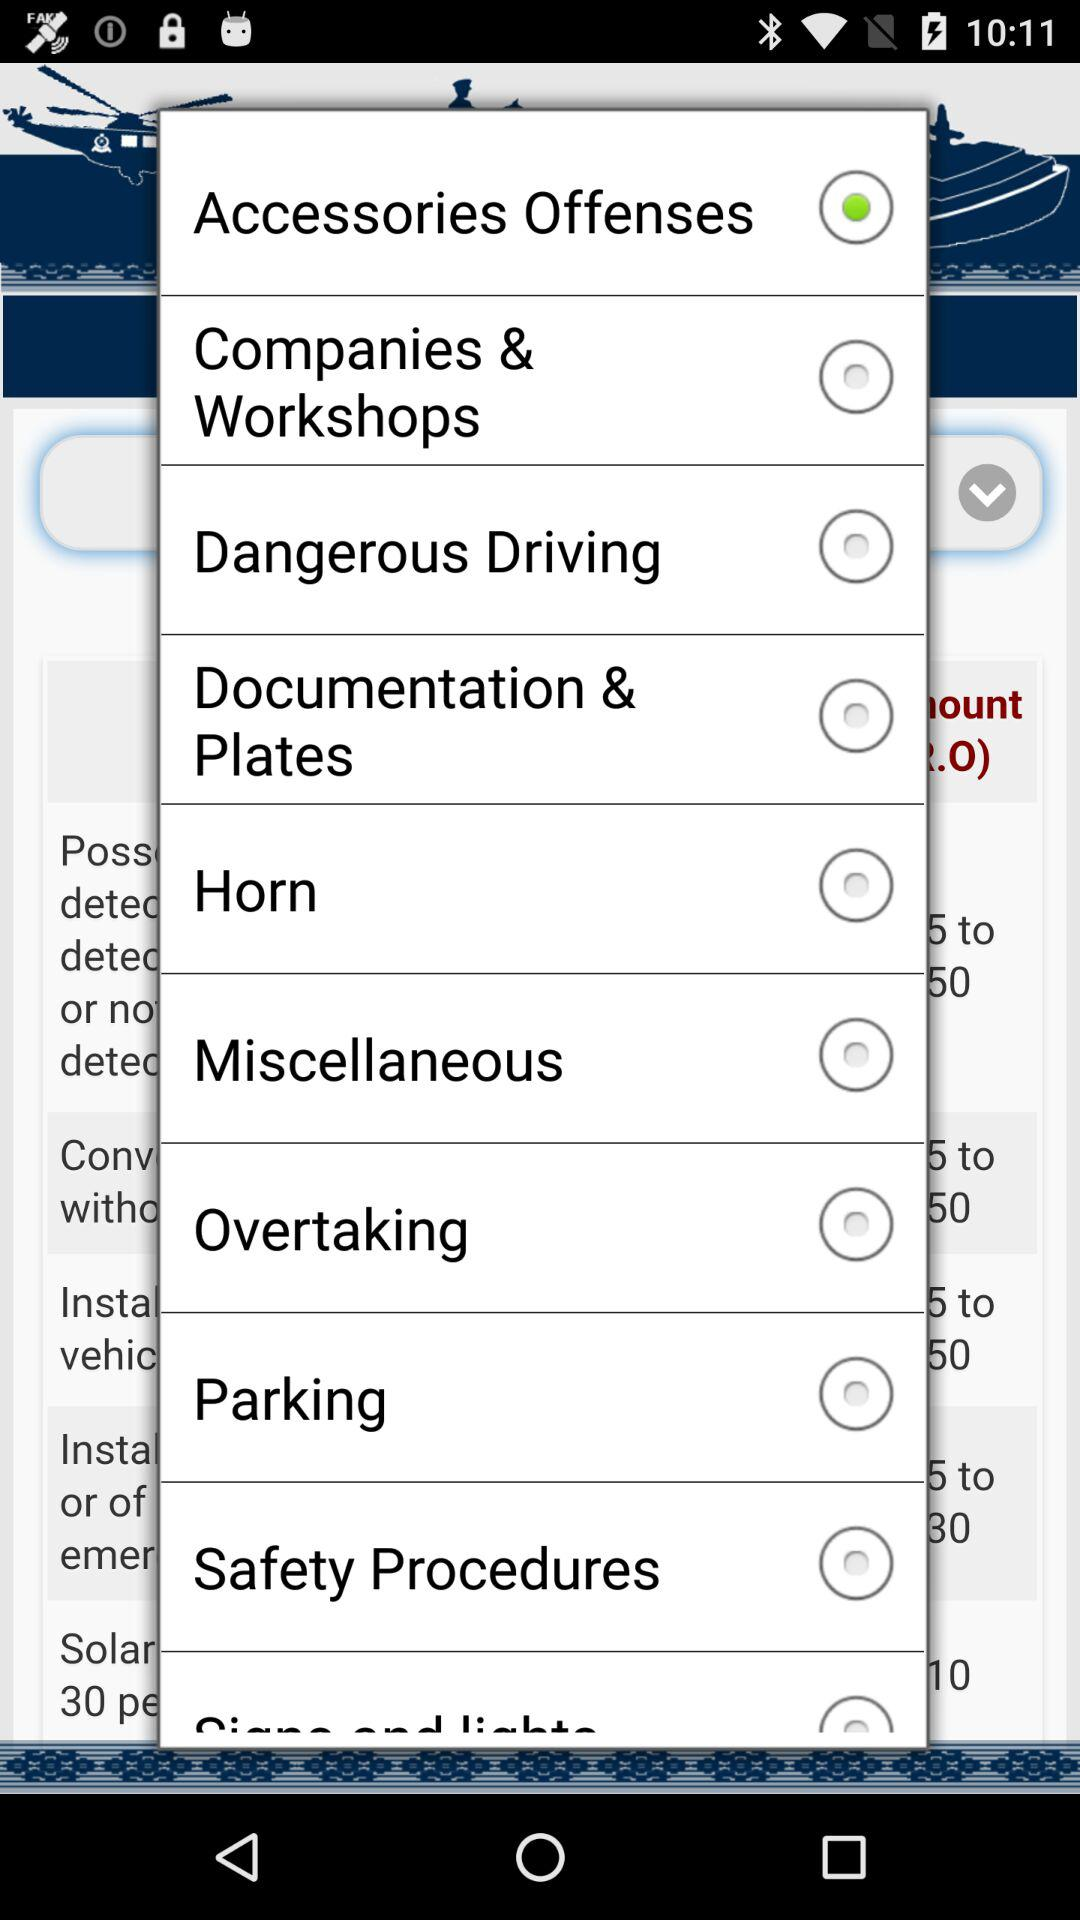Which radio button is selected? The selected radio button is "Accessories Offenses". 